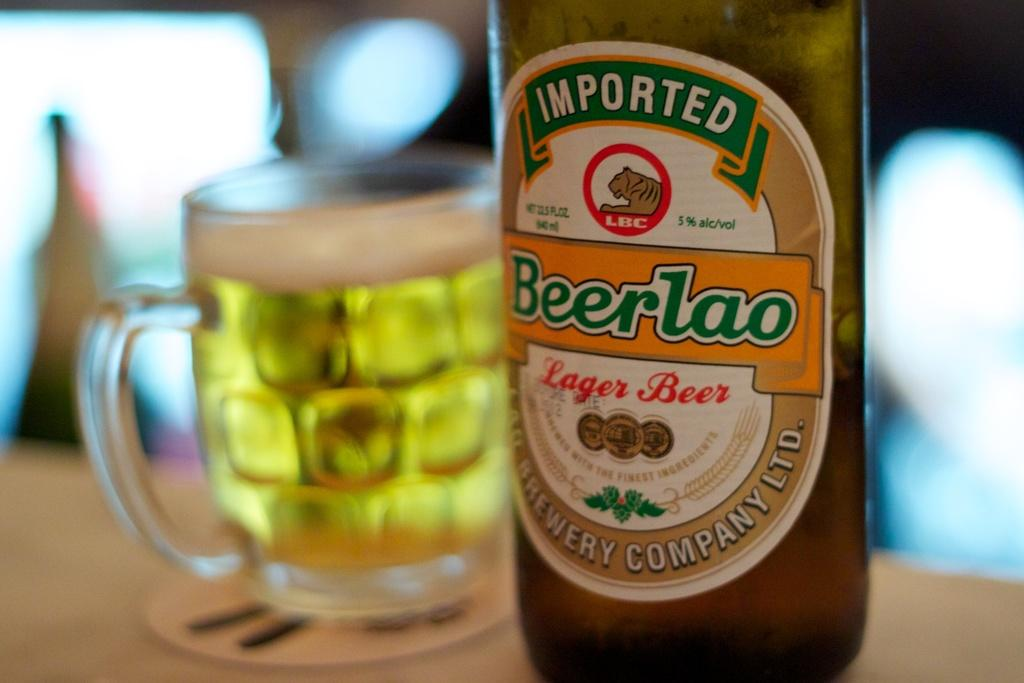Provide a one-sentence caption for the provided image. A bottle of Imported Beerlao beer in front of a cup of beer. 